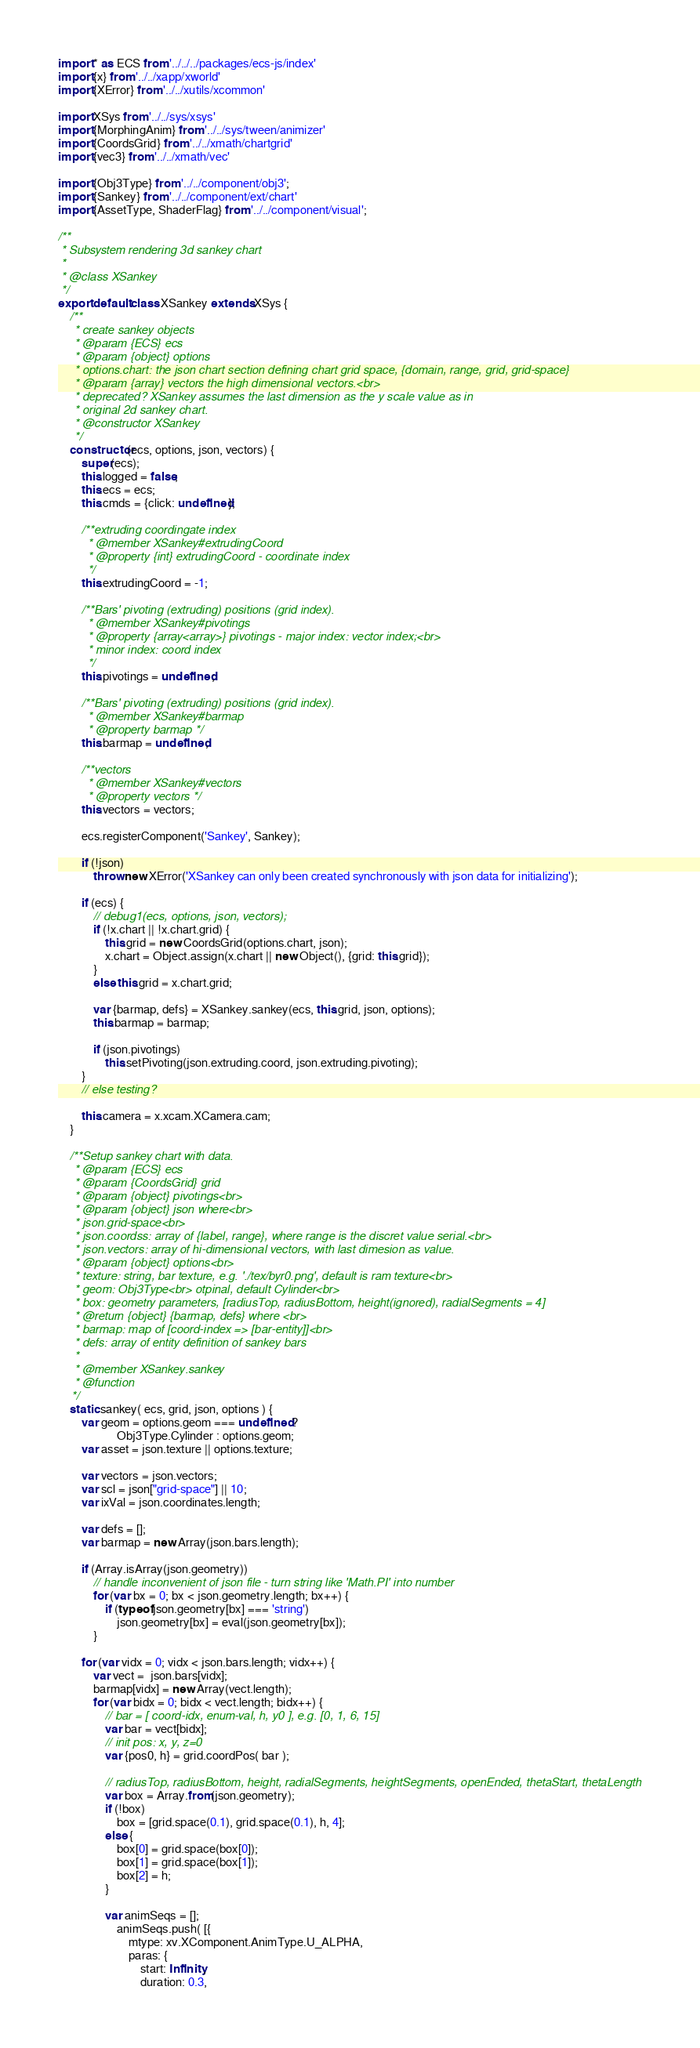<code> <loc_0><loc_0><loc_500><loc_500><_JavaScript_>
import * as ECS from '../../../packages/ecs-js/index'
import {x} from '../../xapp/xworld'
import {XError} from '../../xutils/xcommon'

import XSys from '../../sys/xsys'
import {MorphingAnim} from '../../sys/tween/animizer'
import {CoordsGrid} from '../../xmath/chartgrid'
import {vec3} from '../../xmath/vec'

import {Obj3Type} from '../../component/obj3';
import {Sankey} from '../../component/ext/chart'
import {AssetType, ShaderFlag} from '../../component/visual';

/**
 * Subsystem rendering 3d sankey chart
 *
 * @class XSankey
 */
export default class XSankey extends XSys {
	/**
	 * create sankey objects
	 * @param {ECS} ecs
	 * @param {object} options
	 * options.chart: the json chart section defining chart grid space, {domain, range, grid, grid-space}
	 * @param {array} vectors the high dimensional vectors.<br>
	 * deprecated? XSankey assumes the last dimension as the y scale value as in
	 * original 2d sankey chart.
	 * @constructor XSankey
	 */
	constructor(ecs, options, json, vectors) {
		super(ecs);
		this.logged = false;
		this.ecs = ecs;
		this.cmds = {click: undefined};

		/**extruding coordingate index
		 * @member XSankey#extrudingCoord
		 * @property {int} extrudingCoord - coordinate index
		 */
		this.extrudingCoord = -1;

		/**Bars' pivoting (extruding) positions (grid index).
		 * @member XSankey#pivotings
		 * @property {array<array>} pivotings - major index: vector index;<br>
		 * minor index: coord index
		 */
		this.pivotings = undefined;

		/**Bars' pivoting (extruding) positions (grid index).
		 * @member XSankey#barmap
		 * @property barmap */
		this.barmap = undefined;

		/**vectors
		 * @member XSankey#vectors
		 * @property vectors */
		this.vectors = vectors;

		ecs.registerComponent('Sankey', Sankey);

		if (!json)
			throw new XError('XSankey can only been created synchronously with json data for initializing');

		if (ecs) {
			// debug1(ecs, options, json, vectors);
			if (!x.chart || !x.chart.grid) {
				this.grid = new CoordsGrid(options.chart, json);
				x.chart = Object.assign(x.chart || new Object(), {grid: this.grid});
			}
			else this.grid = x.chart.grid;

			var {barmap, defs} = XSankey.sankey(ecs, this.grid, json, options);
			this.barmap = barmap;

			if (json.pivotings)
				this.setPivoting(json.extruding.coord, json.extruding.pivoting);
		}
		// else testing?

		this.camera = x.xcam.XCamera.cam;
	}

	/**Setup sankey chart with data.
	 * @param {ECS} ecs
	 * @param {CoordsGrid} grid
	 * @param {object} pivotings<br>
	 * @param {object} json where<br>
	 * json.grid-space<br>
	 * json.coordss: array of {label, range}, where range is the discret value serial.<br>
	 * json.vectors: array of hi-dimensional vectors, with last dimesion as value.
	 * @param {object} options<br>
	 * texture: string, bar texture, e.g. './tex/byr0.png', default is ram texture<br>
	 * geom: Obj3Type<br> otpinal, default Cylinder<br>
	 * box: geometry parameters, [radiusTop, radiusBottom, height(ignored), radialSegments = 4]
	 * @return {object} {barmap, defs} where <br>
	 * barmap: map of [coord-index => [bar-entity]]<br>
	 * defs: array of entity definition of sankey bars
	 *
	 * @member XSankey.sankey
	 * @function
	*/
	static sankey( ecs, grid, json, options ) {
		var geom = options.geom === undefined ?
					Obj3Type.Cylinder : options.geom;
		var asset = json.texture || options.texture;

		var vectors = json.vectors;
		var scl = json["grid-space"] || 10;
		var ixVal = json.coordinates.length;

		var defs = [];
		var barmap = new Array(json.bars.length);

		if (Array.isArray(json.geometry))
			// handle inconvenient of json file - turn string like 'Math.PI' into number
			for (var bx = 0; bx < json.geometry.length; bx++) {
				if (typeof json.geometry[bx] === 'string')
					json.geometry[bx] = eval(json.geometry[bx]);
			}

		for (var vidx = 0; vidx < json.bars.length; vidx++) {
			var vect =  json.bars[vidx];
			barmap[vidx] = new Array(vect.length);
			for (var bidx = 0; bidx < vect.length; bidx++) {
				// bar = [ coord-idx, enum-val, h, y0 ], e.g. [0, 1, 6, 15]
				var bar = vect[bidx];
				// init pos: x, y, z=0
				var {pos0, h} = grid.coordPos( bar );

				// radiusTop, radiusBottom, height, radialSegments, heightSegments, openEnded, thetaStart, thetaLength
				var box = Array.from(json.geometry);
				if (!box)
					box = [grid.space(0.1), grid.space(0.1), h, 4];
				else {
					box[0] = grid.space(box[0]);
					box[1] = grid.space(box[1]);
					box[2] = h;
				}

				var animSeqs = [];
					animSeqs.push( [{
						mtype: xv.XComponent.AnimType.U_ALPHA,
						paras: {
							start: Infinity,
							duration: 0.3,</code> 